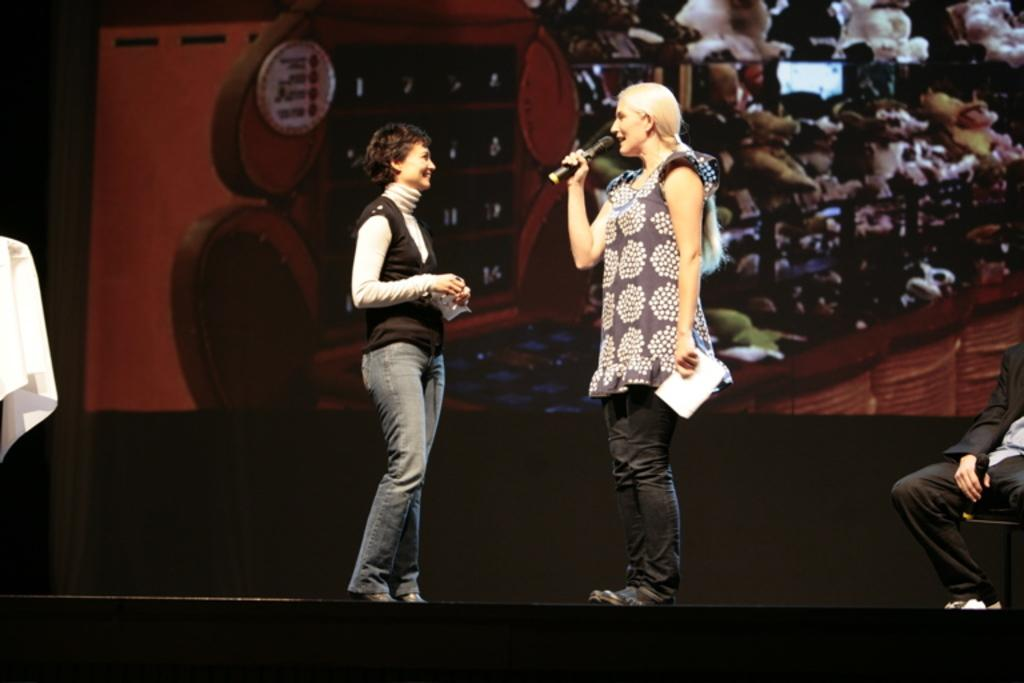How many women are present in the image? There are two women standing in the image. What is one of the women holding in her hands? One of the women is holding a microphone and a paper in her hands. What is the position of the person holding a microphone in the image? The person holding a microphone is sitting on a chair. Can you describe any additional elements in the image? There appears to be a banner in the image. What type of bomb is hidden behind the banner in the image? There is no bomb present in the image; it only features two women, a person sitting on a chair, and a banner. 